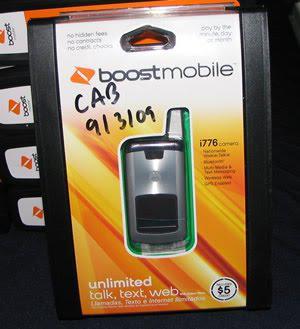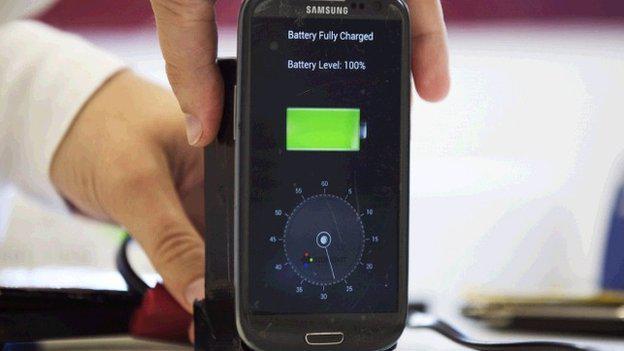The first image is the image on the left, the second image is the image on the right. For the images displayed, is the sentence "All of the phones are flip-phones; they can be physically unfolded to open them." factually correct? Answer yes or no. No. The first image is the image on the left, the second image is the image on the right. For the images displayed, is the sentence "Every phone is a flip phone." factually correct? Answer yes or no. No. 